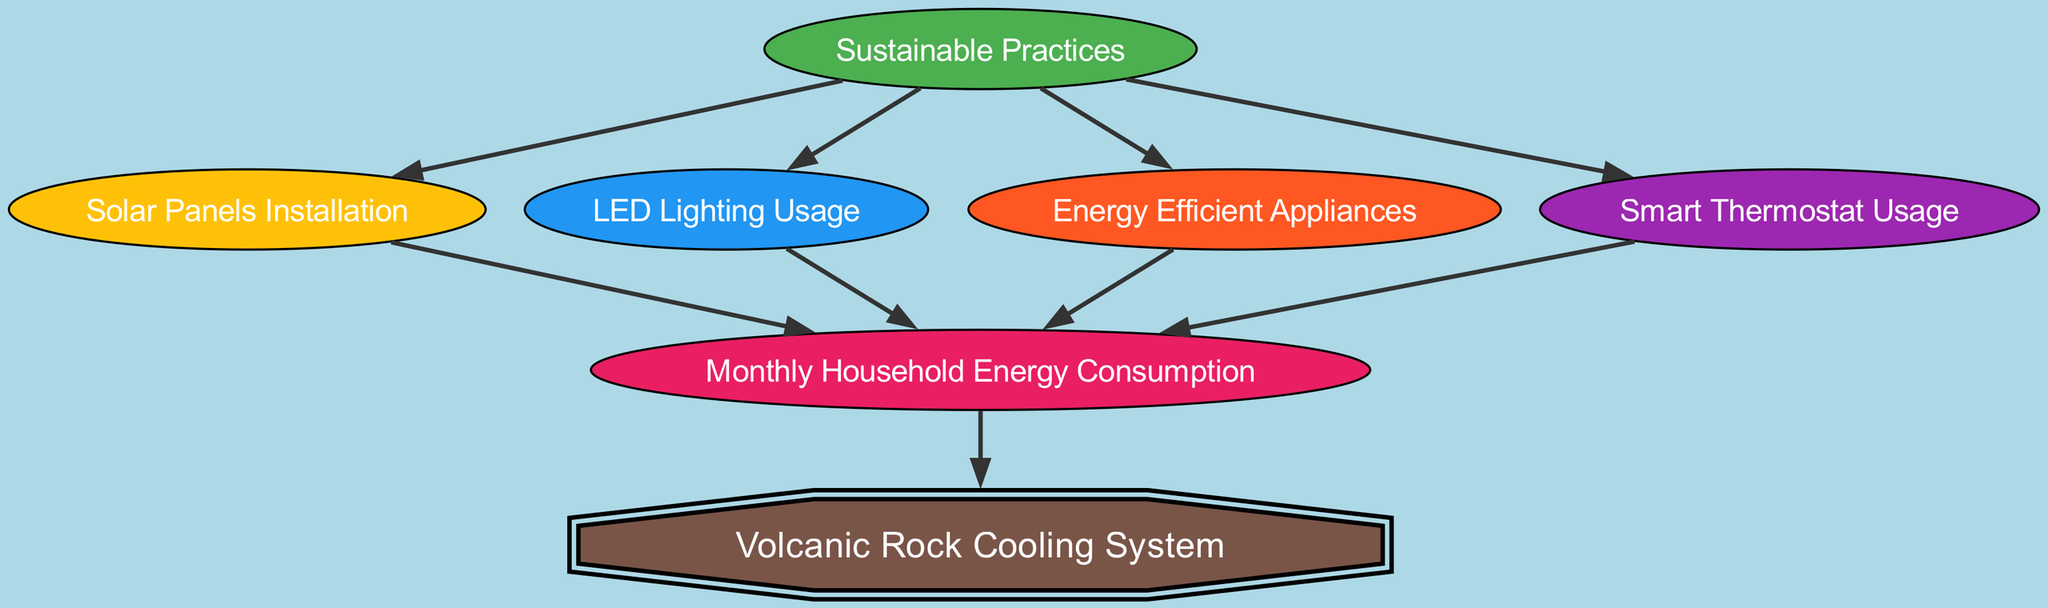What's the total number of nodes in the diagram? The diagram contains seven distinct nodes, which are Sustainable Practices, Solar Panels Installation, LED Lighting Usage, Energy Efficient Appliances, Smart Thermostat Usage, Monthly Household Energy Consumption, and Volcanic Rock Cooling System.
Answer: 7 Which node is connected to the Smart Thermostat? The Smart Thermostat is connected to the Monthly Household Energy Consumption node, indicating that the use of a smart thermostat influences the household's energy consumption.
Answer: Monthly Household Energy Consumption What color represents Energy Efficient Appliances in the diagram? Energy Efficient Appliances is represented in orange color, as indicated by the specified color palette defined in the graph generation code.
Answer: Orange Which sustainable practice has the most direct influence on Household Energy Consumption? All sustainable practices have a direct influence on Household Energy Consumption, but they all lead to it in a similar manner, so no single practice has more influence than the others directly.
Answer: All sustainable practices How many edges connect Sustainable Practices to other nodes? The Sustainable Practices node connects to four other nodes: Solar Panels Installation, LED Lighting Usage, Energy Efficient Appliances, and Smart Thermostat Usage, resulting in a total of four edges.
Answer: 4 If a household implements all sustainable practices, what is the impact on the Volcanic Rock Cooling System? The Volcanic Rock Cooling System is influenced by the Monthly Household Energy Consumption, which is directly affected by all sustainable practices, implying that energy savings from these practices could lead to an increased efficiency of volcanic rock cooling.
Answer: Increased efficiency What is the relationship between Household Energy Consumption and Volcanic Rock Cooling System? The diagram shows a direct edge from Household Energy Consumption to Volcanic Rock Cooling System, indicating that the household's energy consumption level has a direct impact on how the volcanic rock cooling system operates.
Answer: Direct relationship How many edges are there in total in the diagram? The diagram contains a total of eight edges, linking the various nodes in relationships that dictate energy consumption influences.
Answer: 8 Which node serves as the main target for all Sustainable Practices? The main target of all Sustainable Practices is the Monthly Household Energy Consumption, as it receives connections from all four practices.
Answer: Monthly Household Energy Consumption 